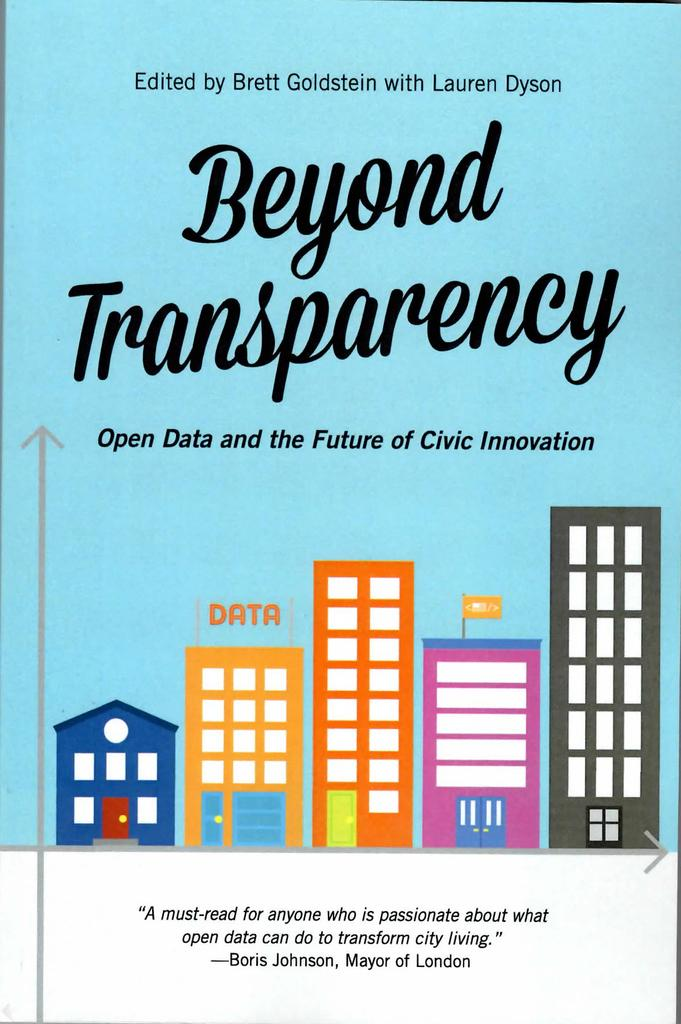<image>
Present a compact description of the photo's key features. Beyond Transparency book that is a must read 